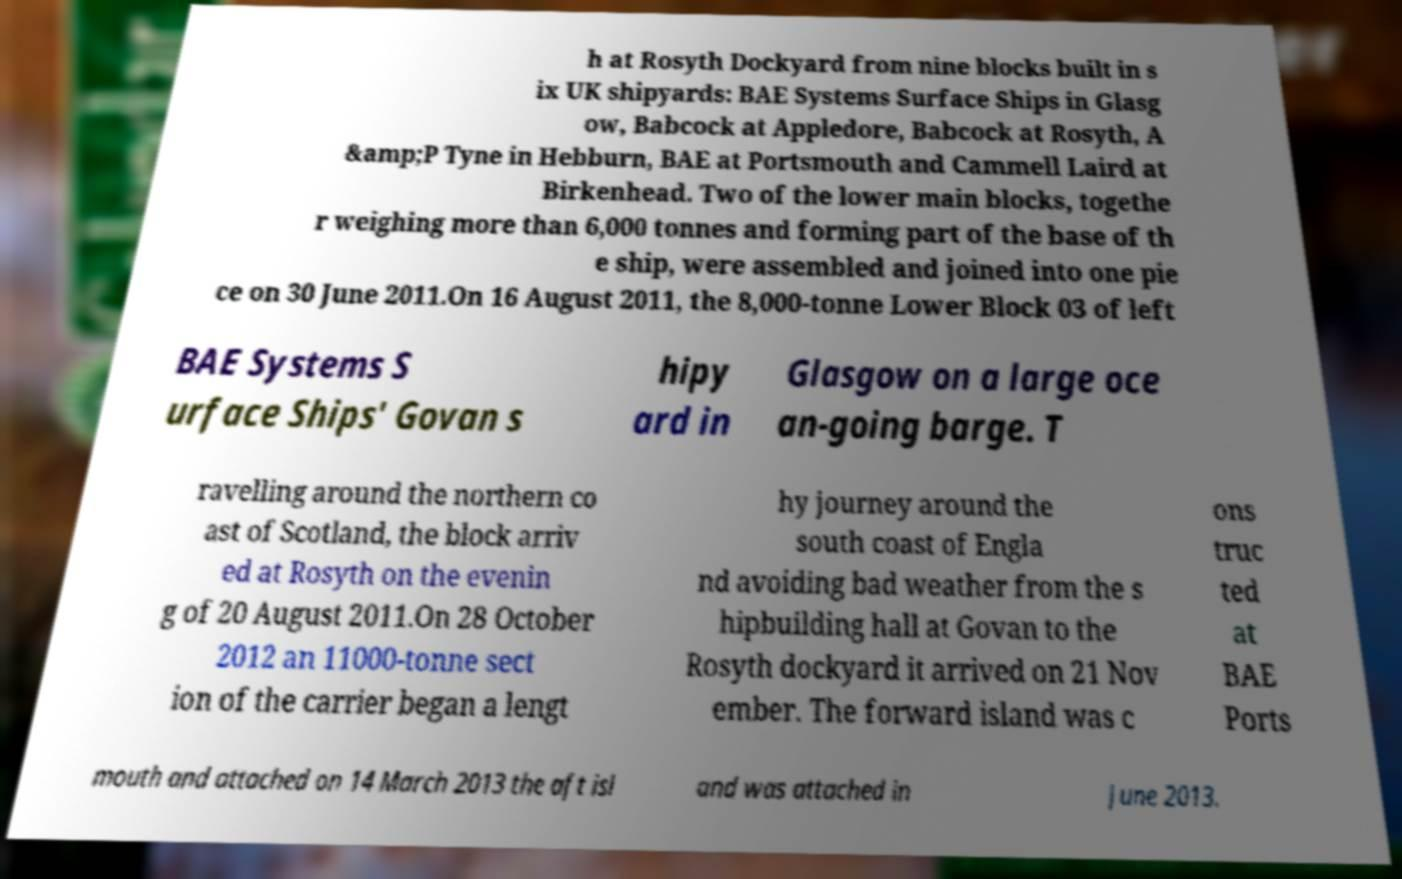Please read and relay the text visible in this image. What does it say? h at Rosyth Dockyard from nine blocks built in s ix UK shipyards: BAE Systems Surface Ships in Glasg ow, Babcock at Appledore, Babcock at Rosyth, A &amp;P Tyne in Hebburn, BAE at Portsmouth and Cammell Laird at Birkenhead. Two of the lower main blocks, togethe r weighing more than 6,000 tonnes and forming part of the base of th e ship, were assembled and joined into one pie ce on 30 June 2011.On 16 August 2011, the 8,000-tonne Lower Block 03 of left BAE Systems S urface Ships' Govan s hipy ard in Glasgow on a large oce an-going barge. T ravelling around the northern co ast of Scotland, the block arriv ed at Rosyth on the evenin g of 20 August 2011.On 28 October 2012 an 11000-tonne sect ion of the carrier began a lengt hy journey around the south coast of Engla nd avoiding bad weather from the s hipbuilding hall at Govan to the Rosyth dockyard it arrived on 21 Nov ember. The forward island was c ons truc ted at BAE Ports mouth and attached on 14 March 2013 the aft isl and was attached in June 2013. 